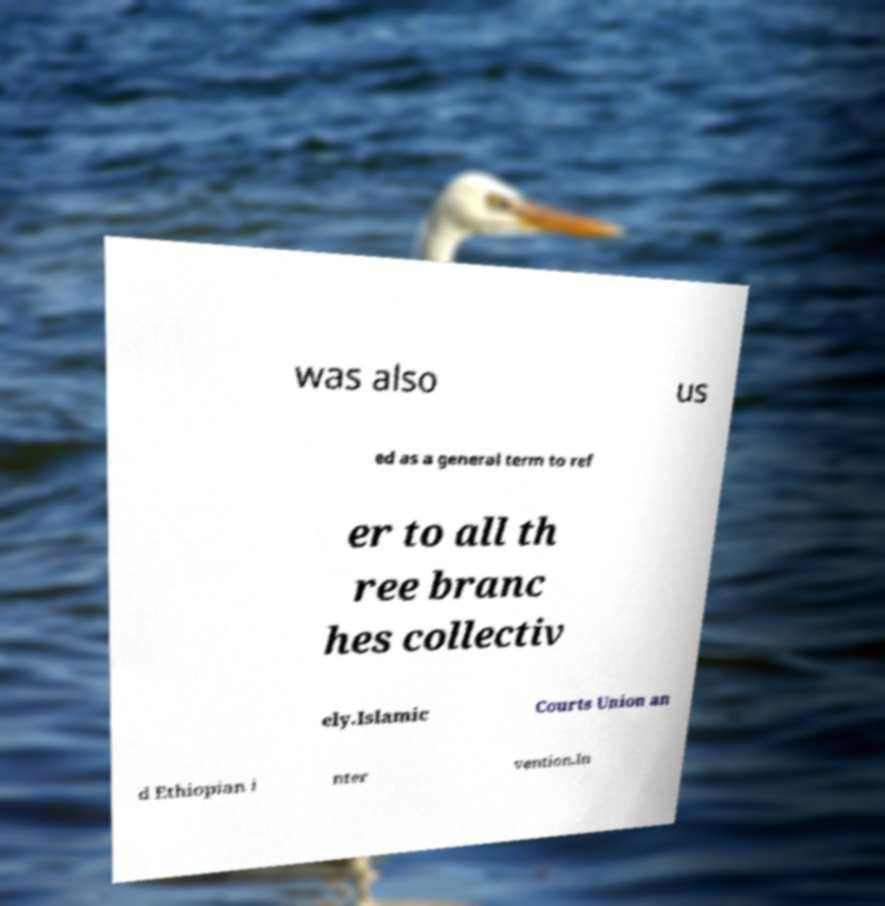Could you assist in decoding the text presented in this image and type it out clearly? was also us ed as a general term to ref er to all th ree branc hes collectiv ely.Islamic Courts Union an d Ethiopian i nter vention.In 